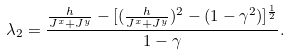<formula> <loc_0><loc_0><loc_500><loc_500>\lambda _ { 2 } = \frac { \frac { h } { J ^ { x } + J ^ { y } } - [ ( \frac { h } { J ^ { x } + J ^ { y } } ) ^ { 2 } - ( 1 - \gamma ^ { 2 } ) ] ^ { \frac { 1 } { 2 } } } { 1 - \gamma } .</formula> 